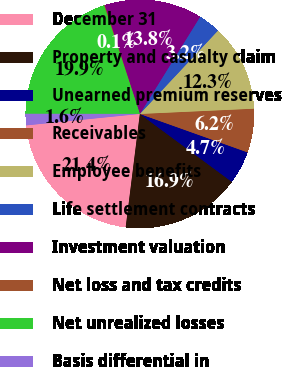Convert chart. <chart><loc_0><loc_0><loc_500><loc_500><pie_chart><fcel>December 31<fcel>Property and casualty claim<fcel>Unearned premium reserves<fcel>Receivables<fcel>Employee benefits<fcel>Life settlement contracts<fcel>Investment valuation<fcel>Net loss and tax credits<fcel>Net unrealized losses<fcel>Basis differential in<nl><fcel>21.42%<fcel>16.85%<fcel>4.67%<fcel>6.19%<fcel>12.28%<fcel>3.15%<fcel>13.81%<fcel>0.1%<fcel>19.9%<fcel>1.62%<nl></chart> 